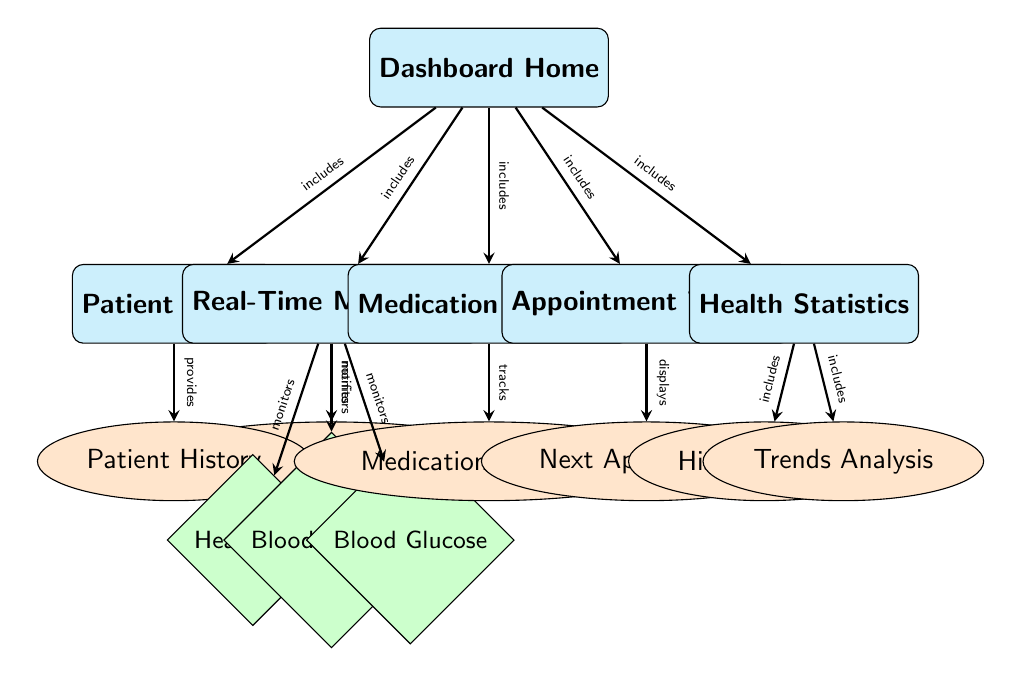What is the central component of the dashboard? The central component in the diagram is labeled "Dashboard Home," which serves as the main entry point to access various features and sections related to health monitoring.
Answer: Dashboard Home How many sections are in the dashboard? There are six sections in the dashboard: Patient Profile, Real-Time Monitoring, Medication Schedule, Appointment Tracker, Health Statistics, and Dashboard Home.
Answer: 6 What feature is associated with patient history? The feature associated with patient history is labeled "Patient History," which is connected to the "Patient Profile" section.
Answer: Patient History What does the "Real-Time Monitoring" section monitor? The "Real-Time Monitoring" section monitors heart rate, blood pressure, and blood glucose, as indicated by the three metric nodes connected to it.
Answer: Heart Rate, Blood Pressure, Blood Glucose Which feature displays upcoming appointments? The feature that displays upcoming appointments is labeled "Next Appointment," which connects to the "Appointment Tracker" section.
Answer: Next Appointment What type of relationship exists between "Real-Time Monitoring" and "Alerts & Notifications"? The relationship is that "Real-Time Monitoring" notifies patients through the "Alerts & Notifications" feature, indicating a link between monitoring health metrics and providing alerts.
Answer: Notifies How many features does the "Health Statistics" section include? The "Health Statistics" section includes two features: Historical Data and Trends Analysis, meaning it incorporates both to provide comprehensive statistical insights.
Answer: 2 What does the "Medication Schedule" section track? The "Medication Schedule" section specifically tracks "Medication Adherence," indicating its function in helping patients stay on schedule with their medications.
Answer: Medication Adherence Which section provides alerts about monitored metrics? The "Real-Time Monitoring" section provides alerts about monitored metrics, as shown by the connection to the "Alerts & Notifications" feature.
Answer: Real-Time Monitoring 